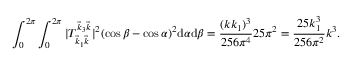<formula> <loc_0><loc_0><loc_500><loc_500>\int _ { 0 } ^ { 2 \pi } \int _ { 0 } ^ { 2 \pi } | T _ { \vec { k } _ { 1 } \vec { k } } ^ { \vec { k } _ { 3 } \vec { k } } | ^ { 2 } ( \cos \beta - \cos \alpha ) ^ { 2 } \mathrm d \alpha \mathrm d \beta = \frac { ( k k _ { 1 } ) ^ { 3 } } { 2 5 6 \pi ^ { 4 } } 2 5 \pi ^ { 2 } = \frac { 2 5 k _ { 1 } ^ { 3 } } { 2 5 6 \pi ^ { 2 } } k ^ { 3 } .</formula> 